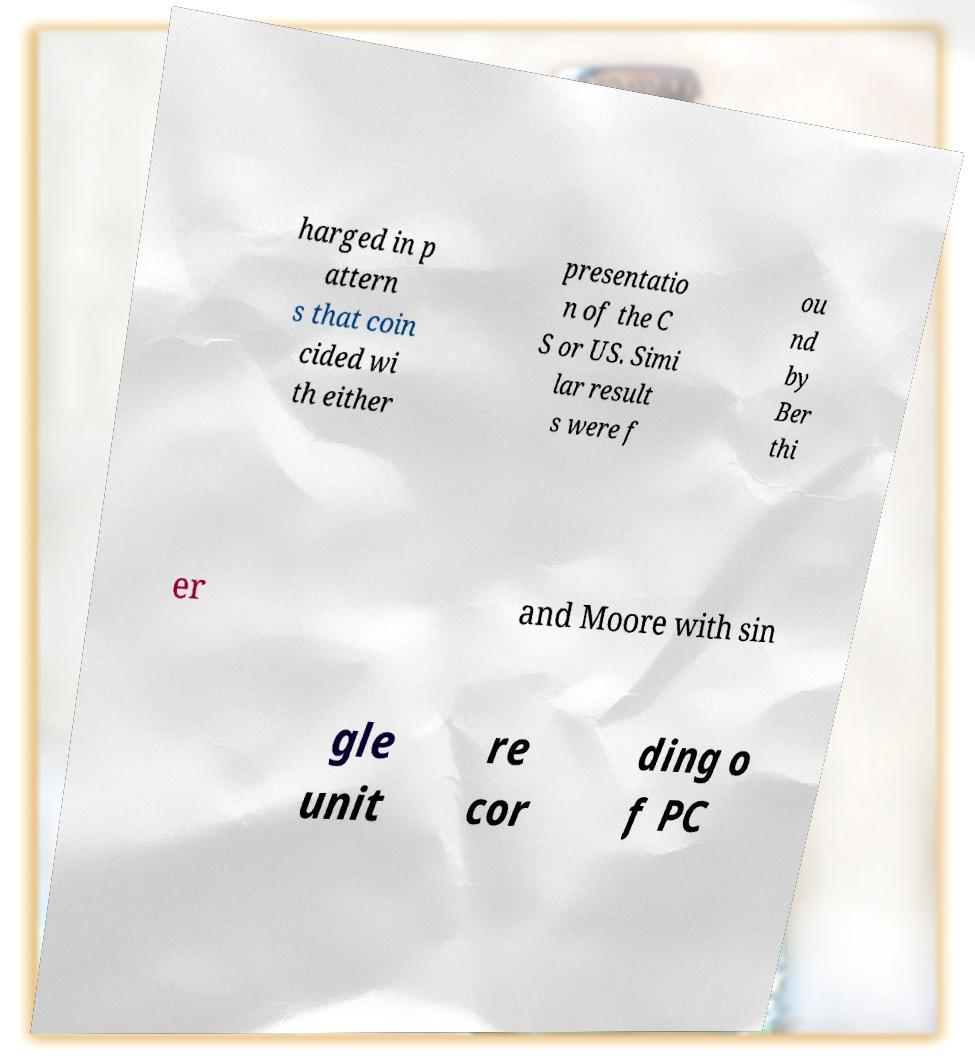Could you extract and type out the text from this image? harged in p attern s that coin cided wi th either presentatio n of the C S or US. Simi lar result s were f ou nd by Ber thi er and Moore with sin gle unit re cor ding o f PC 